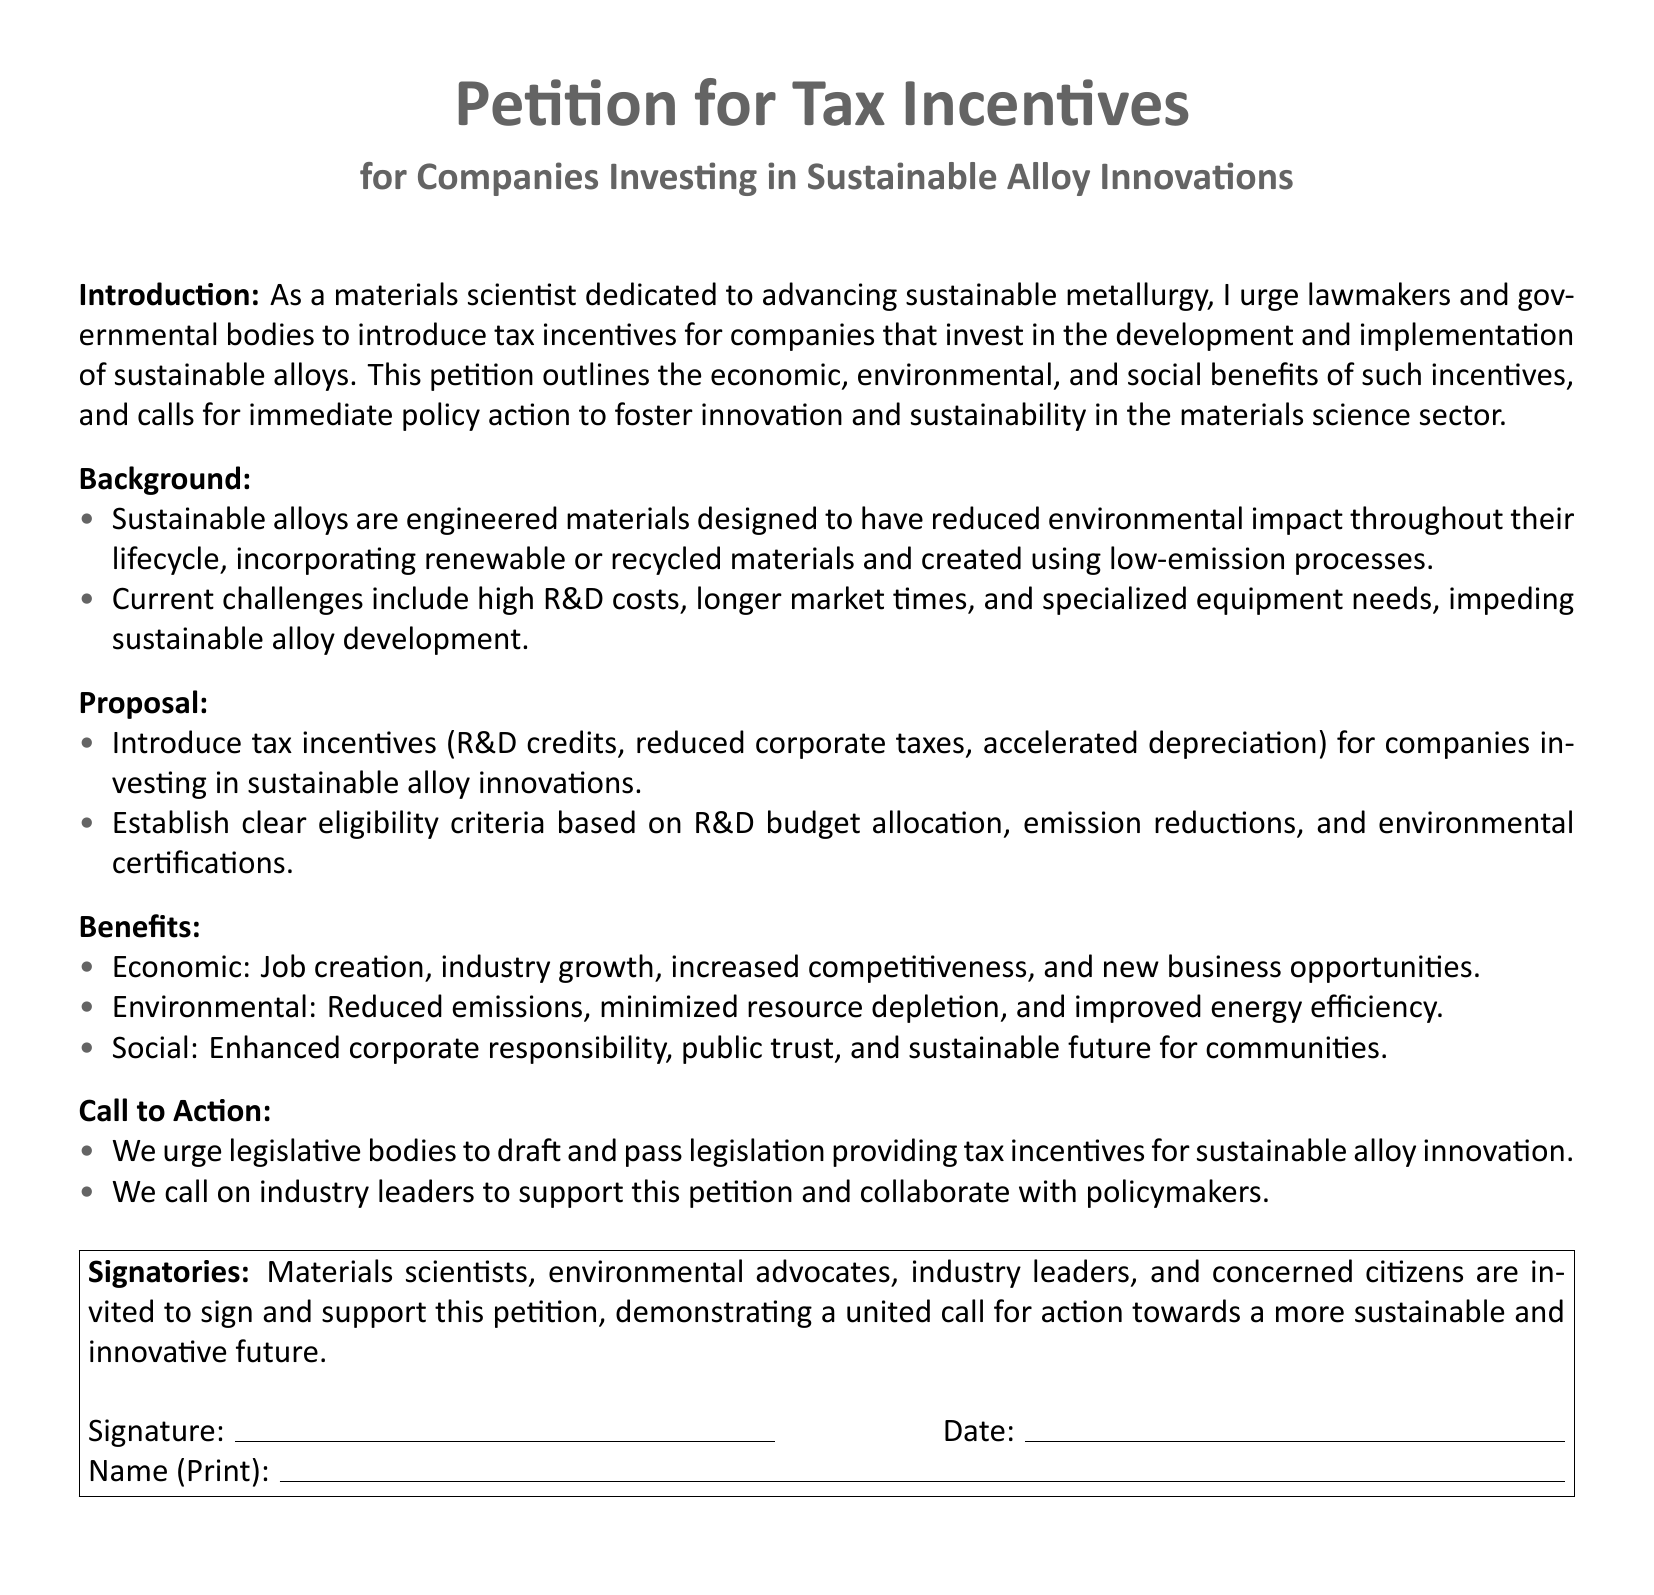What is the main purpose of the petition? The petition aims to encourage legislative bodies to introduce tax incentives for companies that invest in sustainable alloy innovations.
Answer: Encourage tax incentives What are the suggested tax incentives? The proposal includes R&D credits, reduced corporate taxes, and accelerated depreciation for companies.
Answer: R&D credits, reduced corporate taxes, accelerated depreciation Who should draft the legislation? The petition urges legislative bodies to draft and pass the legislation providing tax incentives.
Answer: Legislative bodies What are the environmental benefits mentioned? Environmental benefits include reduced emissions, minimized resource depletion, and improved energy efficiency.
Answer: Reduced emissions, minimized resource depletion, improved energy efficiency Who is invited to sign the petition? Signatories invited include materials scientists, environmental advocates, industry leaders, and concerned citizens.
Answer: Materials scientists, environmental advocates, industry leaders, concerned citizens What type of materials do sustainable alloys use? Sustainable alloys are engineered to use renewable or recycled materials.
Answer: Renewable or recycled materials What is a current challenge in developing sustainable alloys? High R&D costs are mentioned as a current challenge in developing sustainable alloys.
Answer: High R&D costs What does the petition call for regarding industry leaders? The petition calls on industry leaders to support the petition and collaborate with policymakers.
Answer: Support the petition What color is used for the title of the petition? The title of the petition is in metallic gray color.
Answer: Metallic gray 